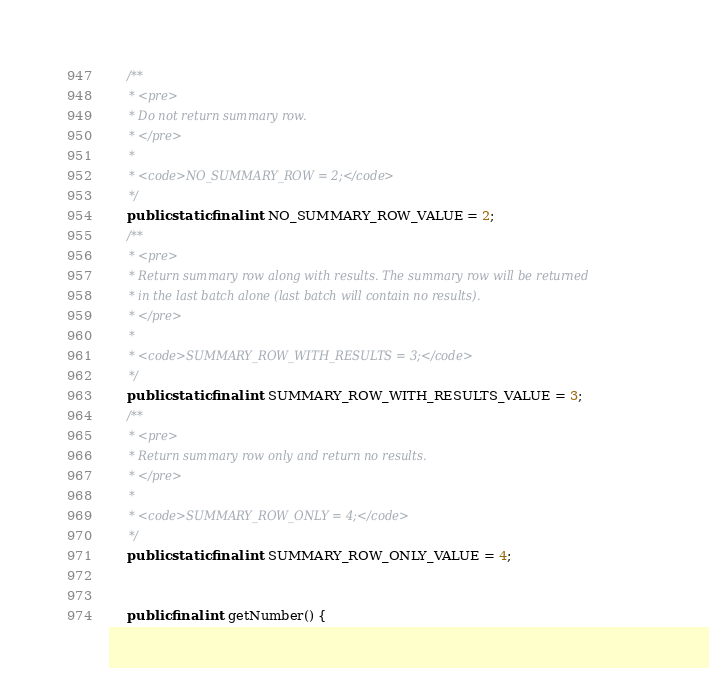Convert code to text. <code><loc_0><loc_0><loc_500><loc_500><_Java_>    /**
     * <pre>
     * Do not return summary row.
     * </pre>
     *
     * <code>NO_SUMMARY_ROW = 2;</code>
     */
    public static final int NO_SUMMARY_ROW_VALUE = 2;
    /**
     * <pre>
     * Return summary row along with results. The summary row will be returned
     * in the last batch alone (last batch will contain no results).
     * </pre>
     *
     * <code>SUMMARY_ROW_WITH_RESULTS = 3;</code>
     */
    public static final int SUMMARY_ROW_WITH_RESULTS_VALUE = 3;
    /**
     * <pre>
     * Return summary row only and return no results.
     * </pre>
     *
     * <code>SUMMARY_ROW_ONLY = 4;</code>
     */
    public static final int SUMMARY_ROW_ONLY_VALUE = 4;


    public final int getNumber() {</code> 